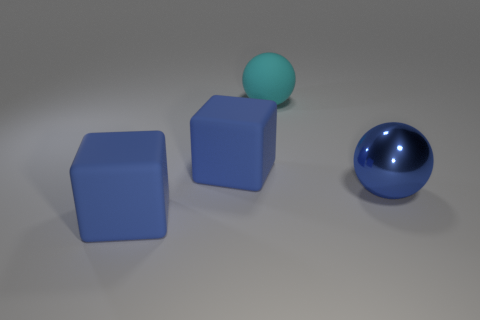Are there any big cyan rubber things to the left of the big blue matte object in front of the big matte block that is behind the blue metal object?
Your answer should be very brief. No. Is the color of the large cube that is in front of the blue ball the same as the big sphere that is in front of the cyan rubber ball?
Your response must be concise. Yes. What is the material of the cyan thing that is the same size as the blue shiny thing?
Give a very brief answer. Rubber. There is a cyan ball that is on the left side of the blue shiny object that is right of the blue thing in front of the blue shiny sphere; what is its size?
Your response must be concise. Large. How many other things are made of the same material as the cyan ball?
Keep it short and to the point. 2. What size is the blue matte cube behind the blue metal ball?
Provide a succinct answer. Large. How many rubber things are both in front of the cyan matte ball and behind the big blue sphere?
Your response must be concise. 1. What material is the large blue sphere that is on the right side of the large blue rubber block that is behind the blue ball?
Your answer should be very brief. Metal. There is a large blue object that is the same shape as the big cyan thing; what is its material?
Make the answer very short. Metal. Are any tiny green matte objects visible?
Keep it short and to the point. No. 